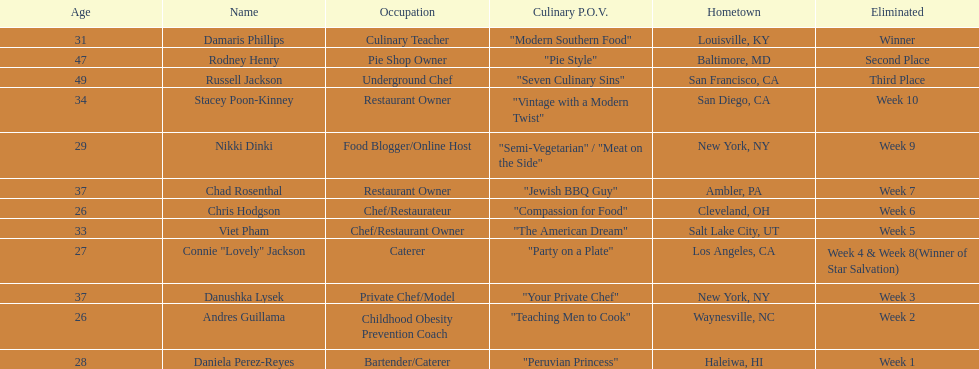Which participant's cooking perspective had a more extended explanation than "vintage with a contemporary twist"? Nikki Dinki. 